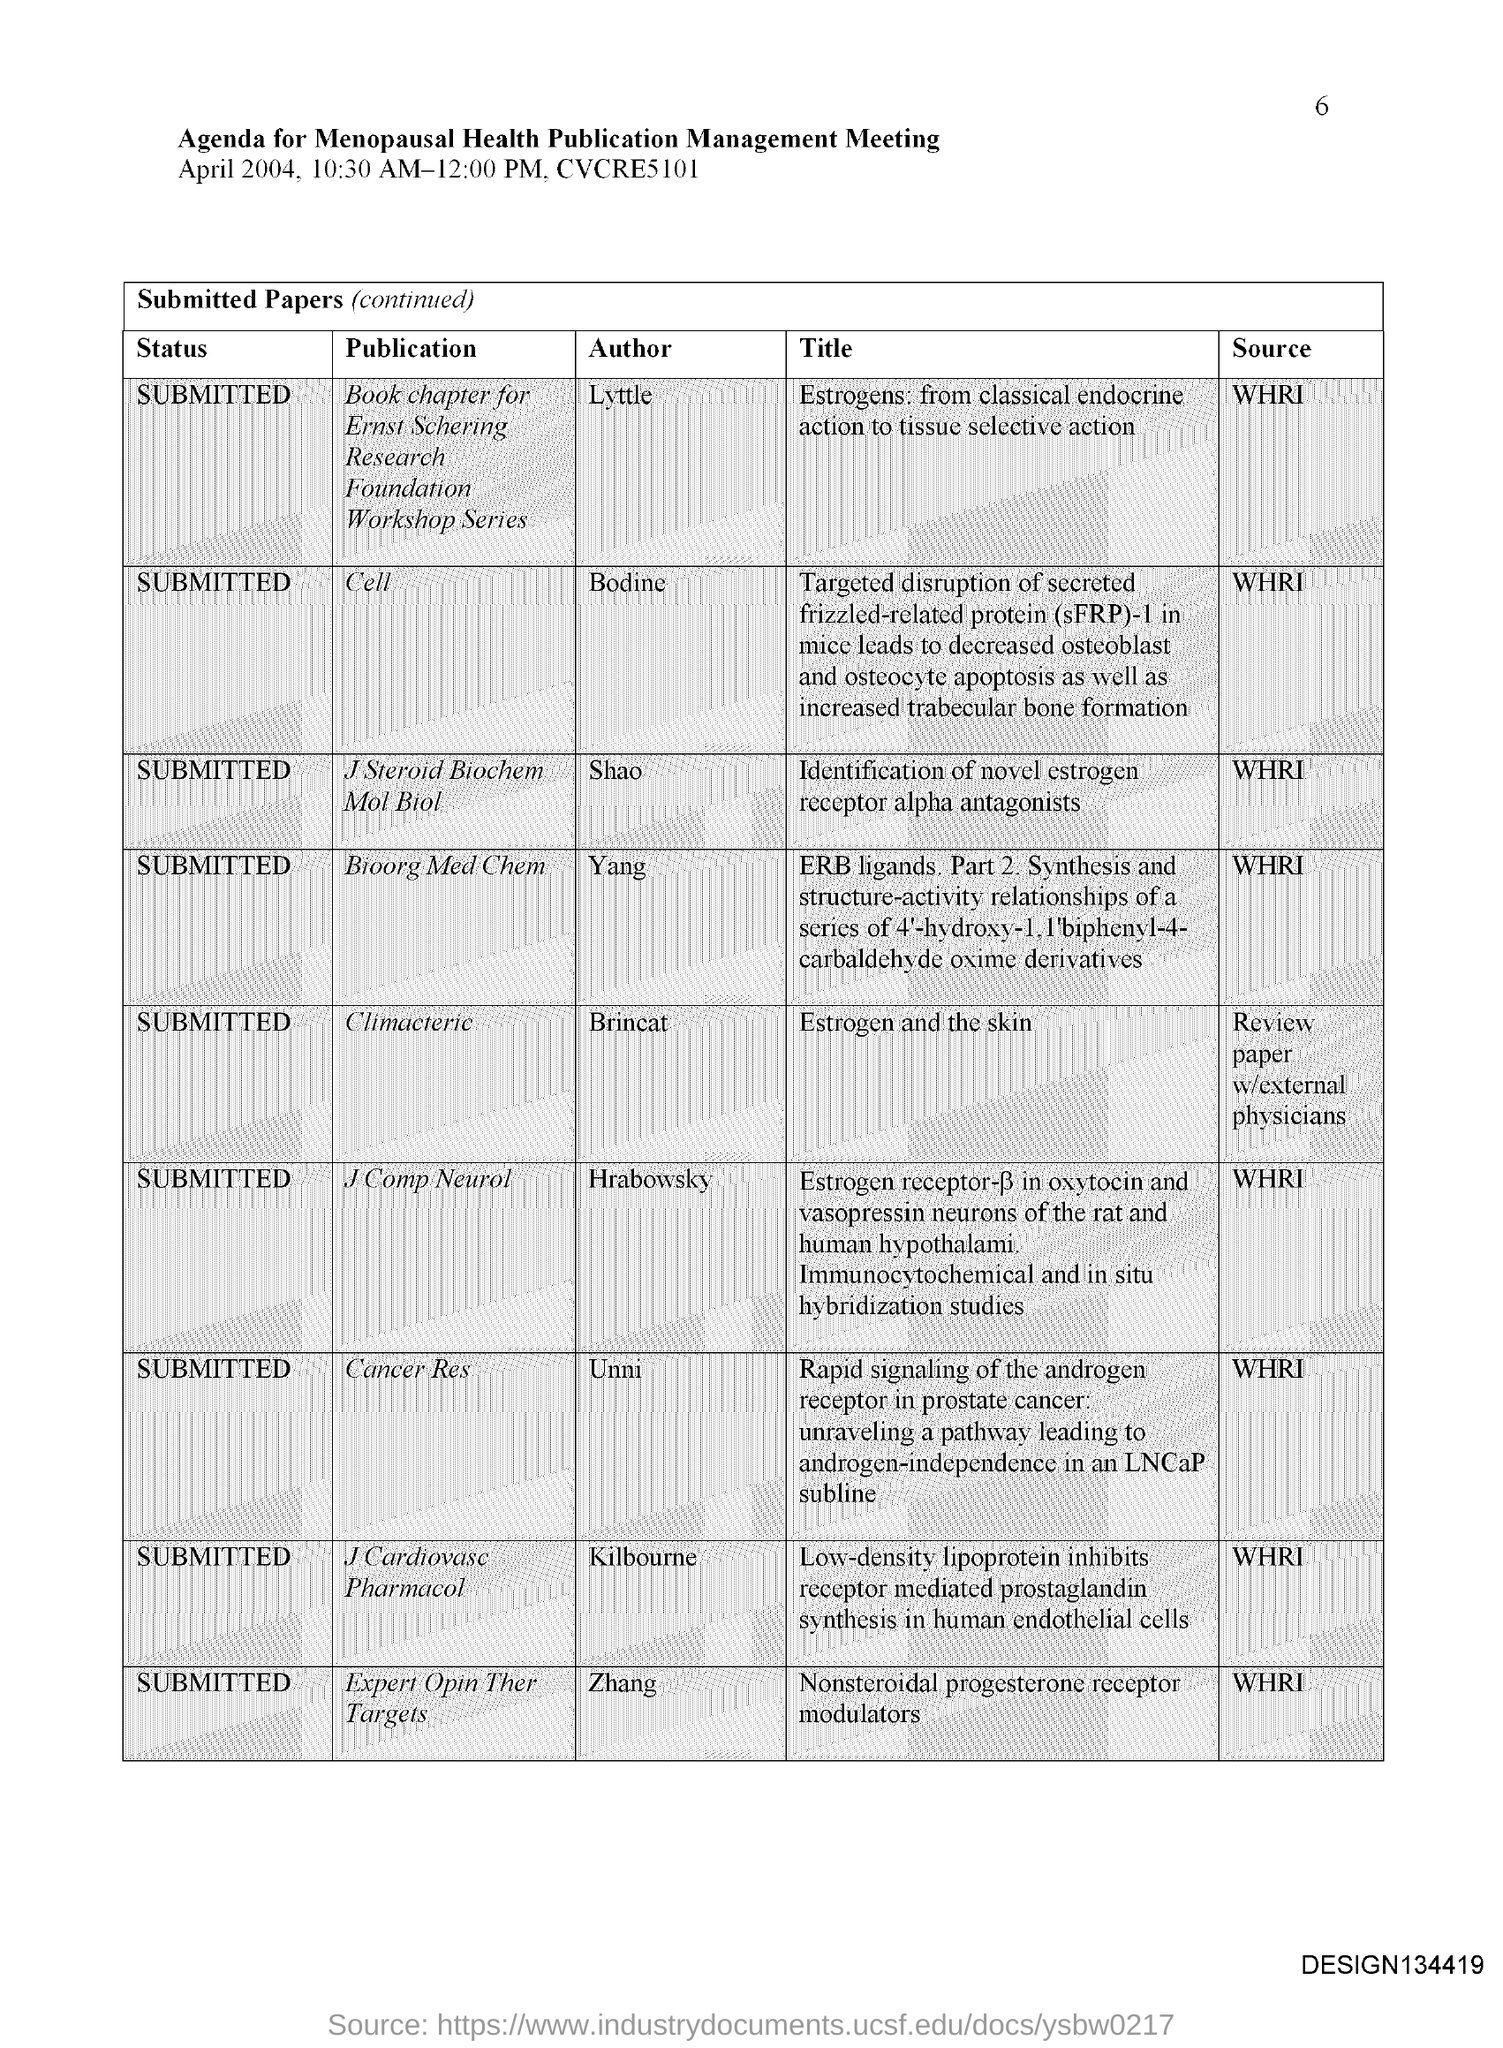Who is the author of the paper titled 'Estrogens: from classical endocrine action to tissue selective action'?
Keep it short and to the point. Lyttle. Who is the author of the paper titled 'Identification of novel estrogen receptor alpha antagonists'?
Give a very brief answer. Shao. What is the status of the paper titled 'Estrogen and the skin'?
Provide a short and direct response. SUBMITTED. What is the source of the paper titled 'Identification of novel estrogen receptor alpha antagonists'?
Ensure brevity in your answer.  WHRI. What is the status of the paper titled 'Nonsteroidal progesterone receptor modulators'?
Your answer should be very brief. Submitted. Who is the author of the paper titled 'Nonsteroidal progesterone receptor modulators'?
Provide a short and direct response. Zhang. What is the source of the paper titled 'Estrogens: from classical endocrine action to tissue selective action'?
Give a very brief answer. WHRI. 